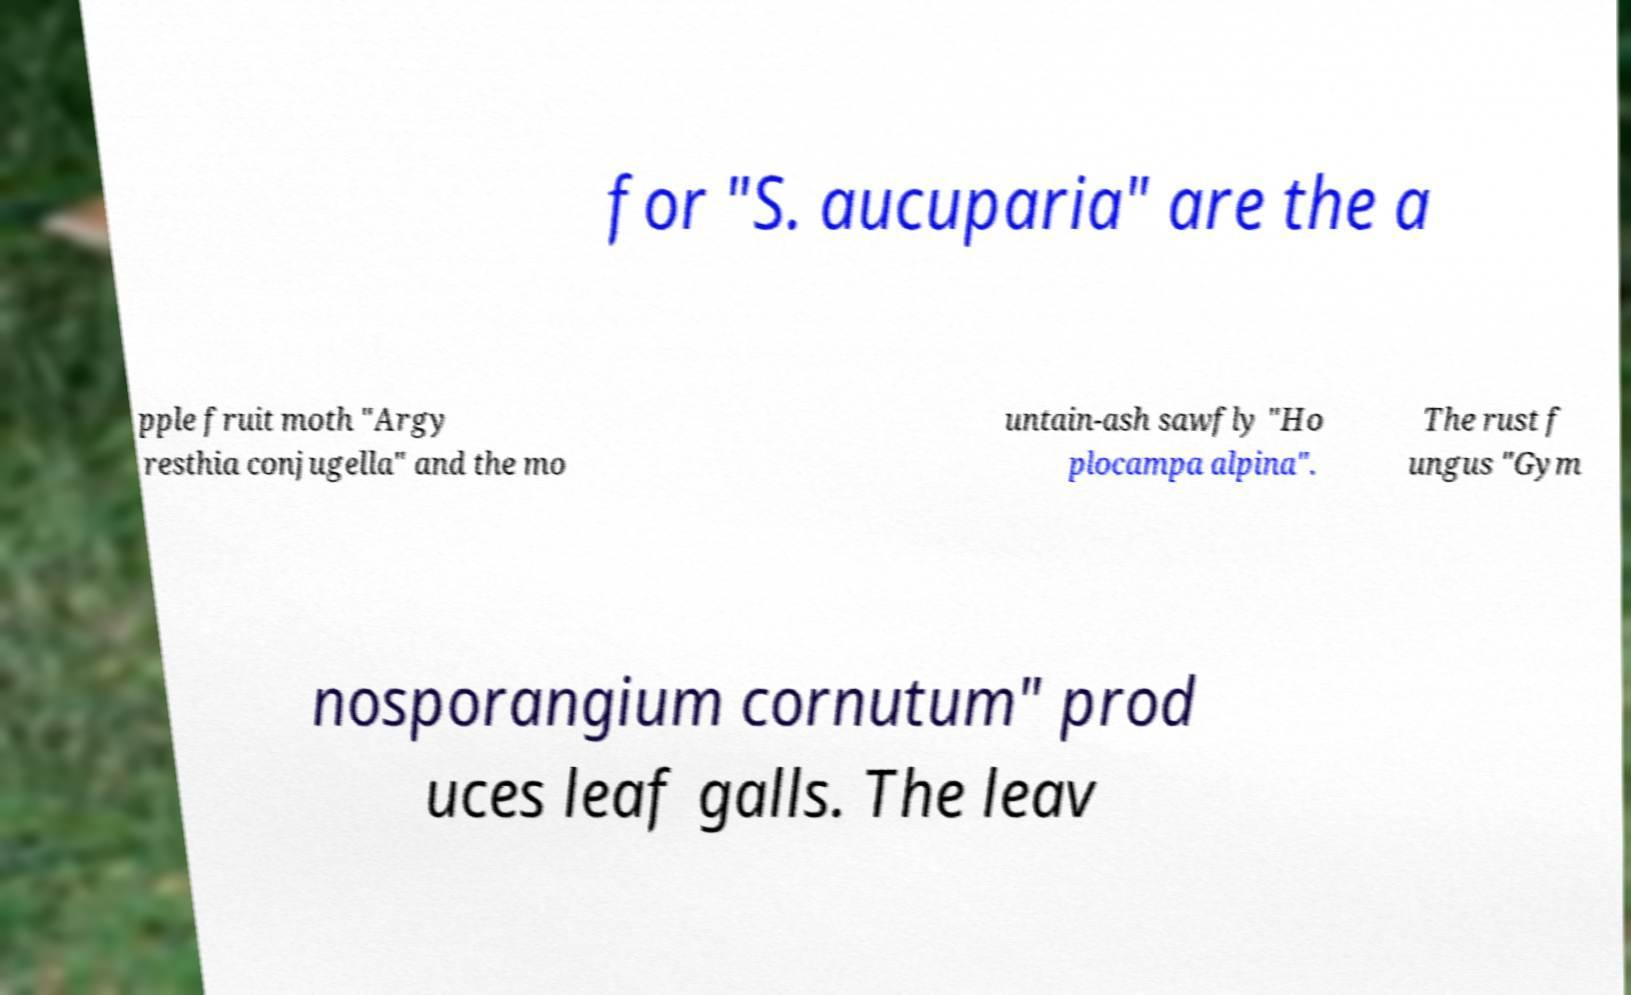Could you extract and type out the text from this image? for "S. aucuparia" are the a pple fruit moth "Argy resthia conjugella" and the mo untain-ash sawfly "Ho plocampa alpina". The rust f ungus "Gym nosporangium cornutum" prod uces leaf galls. The leav 